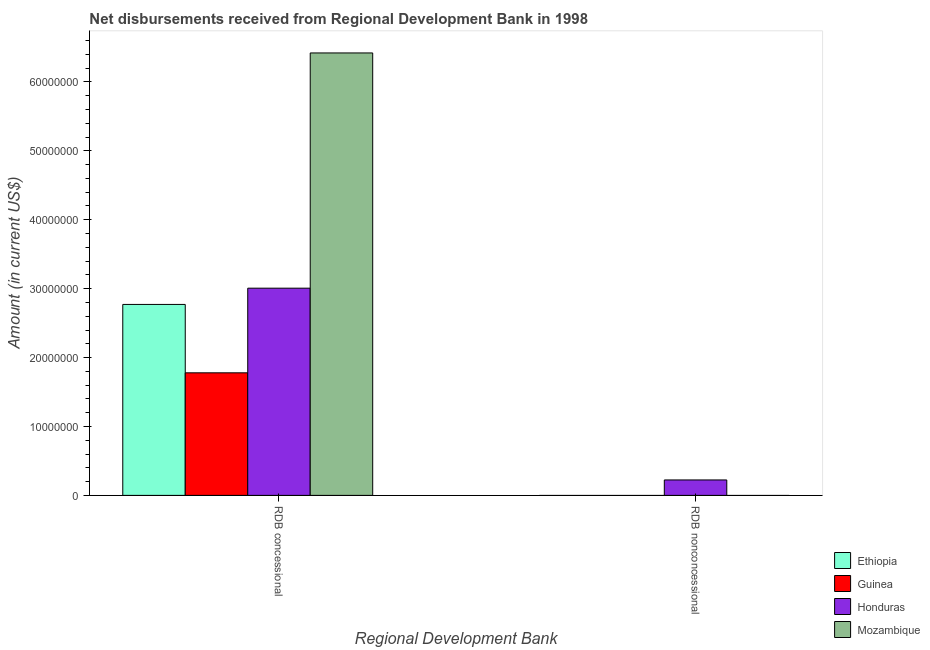How many different coloured bars are there?
Provide a short and direct response. 4. Are the number of bars per tick equal to the number of legend labels?
Your answer should be compact. No. Are the number of bars on each tick of the X-axis equal?
Your response must be concise. No. How many bars are there on the 2nd tick from the right?
Provide a succinct answer. 4. What is the label of the 2nd group of bars from the left?
Keep it short and to the point. RDB nonconcessional. Across all countries, what is the maximum net concessional disbursements from rdb?
Your response must be concise. 6.42e+07. Across all countries, what is the minimum net concessional disbursements from rdb?
Provide a succinct answer. 1.78e+07. In which country was the net non concessional disbursements from rdb maximum?
Offer a terse response. Honduras. What is the total net non concessional disbursements from rdb in the graph?
Ensure brevity in your answer.  2.24e+06. What is the difference between the net concessional disbursements from rdb in Honduras and that in Guinea?
Your answer should be compact. 1.23e+07. What is the difference between the net concessional disbursements from rdb in Honduras and the net non concessional disbursements from rdb in Mozambique?
Give a very brief answer. 3.01e+07. What is the average net non concessional disbursements from rdb per country?
Your answer should be compact. 5.60e+05. What is the difference between the net concessional disbursements from rdb and net non concessional disbursements from rdb in Honduras?
Your response must be concise. 2.78e+07. In how many countries, is the net non concessional disbursements from rdb greater than 40000000 US$?
Keep it short and to the point. 0. What is the ratio of the net concessional disbursements from rdb in Ethiopia to that in Guinea?
Give a very brief answer. 1.56. In how many countries, is the net concessional disbursements from rdb greater than the average net concessional disbursements from rdb taken over all countries?
Provide a short and direct response. 1. Are all the bars in the graph horizontal?
Keep it short and to the point. No. How many countries are there in the graph?
Offer a very short reply. 4. What is the difference between two consecutive major ticks on the Y-axis?
Your answer should be compact. 1.00e+07. Does the graph contain any zero values?
Offer a terse response. Yes. Does the graph contain grids?
Keep it short and to the point. No. Where does the legend appear in the graph?
Your answer should be compact. Bottom right. How many legend labels are there?
Offer a very short reply. 4. What is the title of the graph?
Your response must be concise. Net disbursements received from Regional Development Bank in 1998. Does "Russian Federation" appear as one of the legend labels in the graph?
Provide a short and direct response. No. What is the label or title of the X-axis?
Make the answer very short. Regional Development Bank. What is the label or title of the Y-axis?
Provide a succinct answer. Amount (in current US$). What is the Amount (in current US$) of Ethiopia in RDB concessional?
Offer a terse response. 2.77e+07. What is the Amount (in current US$) in Guinea in RDB concessional?
Make the answer very short. 1.78e+07. What is the Amount (in current US$) in Honduras in RDB concessional?
Ensure brevity in your answer.  3.01e+07. What is the Amount (in current US$) of Mozambique in RDB concessional?
Provide a short and direct response. 6.42e+07. What is the Amount (in current US$) of Ethiopia in RDB nonconcessional?
Provide a succinct answer. 0. What is the Amount (in current US$) in Guinea in RDB nonconcessional?
Your answer should be very brief. 0. What is the Amount (in current US$) in Honduras in RDB nonconcessional?
Your response must be concise. 2.24e+06. What is the Amount (in current US$) in Mozambique in RDB nonconcessional?
Provide a succinct answer. 0. Across all Regional Development Bank, what is the maximum Amount (in current US$) of Ethiopia?
Give a very brief answer. 2.77e+07. Across all Regional Development Bank, what is the maximum Amount (in current US$) of Guinea?
Make the answer very short. 1.78e+07. Across all Regional Development Bank, what is the maximum Amount (in current US$) in Honduras?
Make the answer very short. 3.01e+07. Across all Regional Development Bank, what is the maximum Amount (in current US$) of Mozambique?
Provide a short and direct response. 6.42e+07. Across all Regional Development Bank, what is the minimum Amount (in current US$) of Guinea?
Provide a short and direct response. 0. Across all Regional Development Bank, what is the minimum Amount (in current US$) of Honduras?
Your response must be concise. 2.24e+06. What is the total Amount (in current US$) of Ethiopia in the graph?
Provide a succinct answer. 2.77e+07. What is the total Amount (in current US$) in Guinea in the graph?
Make the answer very short. 1.78e+07. What is the total Amount (in current US$) of Honduras in the graph?
Provide a succinct answer. 3.23e+07. What is the total Amount (in current US$) in Mozambique in the graph?
Your answer should be compact. 6.42e+07. What is the difference between the Amount (in current US$) of Honduras in RDB concessional and that in RDB nonconcessional?
Provide a succinct answer. 2.78e+07. What is the difference between the Amount (in current US$) of Ethiopia in RDB concessional and the Amount (in current US$) of Honduras in RDB nonconcessional?
Your answer should be very brief. 2.55e+07. What is the difference between the Amount (in current US$) in Guinea in RDB concessional and the Amount (in current US$) in Honduras in RDB nonconcessional?
Ensure brevity in your answer.  1.55e+07. What is the average Amount (in current US$) in Ethiopia per Regional Development Bank?
Provide a short and direct response. 1.39e+07. What is the average Amount (in current US$) in Guinea per Regional Development Bank?
Your response must be concise. 8.89e+06. What is the average Amount (in current US$) in Honduras per Regional Development Bank?
Provide a succinct answer. 1.62e+07. What is the average Amount (in current US$) of Mozambique per Regional Development Bank?
Provide a short and direct response. 3.21e+07. What is the difference between the Amount (in current US$) of Ethiopia and Amount (in current US$) of Guinea in RDB concessional?
Offer a terse response. 9.93e+06. What is the difference between the Amount (in current US$) of Ethiopia and Amount (in current US$) of Honduras in RDB concessional?
Provide a succinct answer. -2.36e+06. What is the difference between the Amount (in current US$) of Ethiopia and Amount (in current US$) of Mozambique in RDB concessional?
Make the answer very short. -3.65e+07. What is the difference between the Amount (in current US$) in Guinea and Amount (in current US$) in Honduras in RDB concessional?
Offer a very short reply. -1.23e+07. What is the difference between the Amount (in current US$) in Guinea and Amount (in current US$) in Mozambique in RDB concessional?
Ensure brevity in your answer.  -4.64e+07. What is the difference between the Amount (in current US$) in Honduras and Amount (in current US$) in Mozambique in RDB concessional?
Your answer should be compact. -3.41e+07. What is the ratio of the Amount (in current US$) of Honduras in RDB concessional to that in RDB nonconcessional?
Make the answer very short. 13.41. What is the difference between the highest and the second highest Amount (in current US$) in Honduras?
Keep it short and to the point. 2.78e+07. What is the difference between the highest and the lowest Amount (in current US$) of Ethiopia?
Offer a terse response. 2.77e+07. What is the difference between the highest and the lowest Amount (in current US$) in Guinea?
Make the answer very short. 1.78e+07. What is the difference between the highest and the lowest Amount (in current US$) of Honduras?
Your answer should be very brief. 2.78e+07. What is the difference between the highest and the lowest Amount (in current US$) of Mozambique?
Make the answer very short. 6.42e+07. 